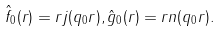<formula> <loc_0><loc_0><loc_500><loc_500>\hat { f } _ { 0 } ( r ) = r j ( q _ { 0 } r ) , \hat { g } _ { 0 } ( r ) = r n ( q _ { 0 } r ) .</formula> 